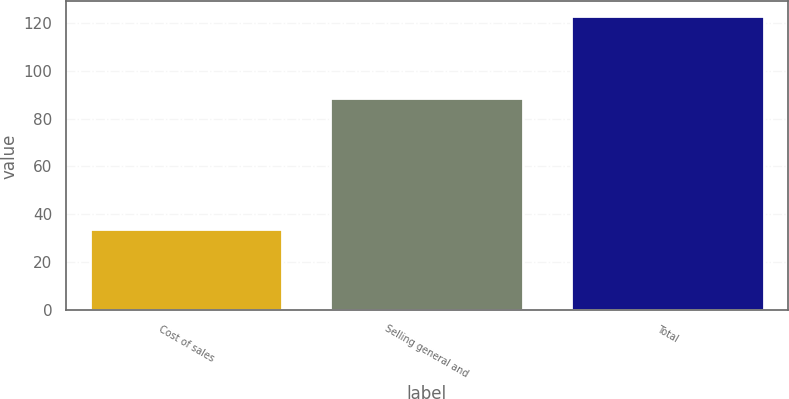Convert chart. <chart><loc_0><loc_0><loc_500><loc_500><bar_chart><fcel>Cost of sales<fcel>Selling general and<fcel>Total<nl><fcel>34.1<fcel>88.6<fcel>122.7<nl></chart> 